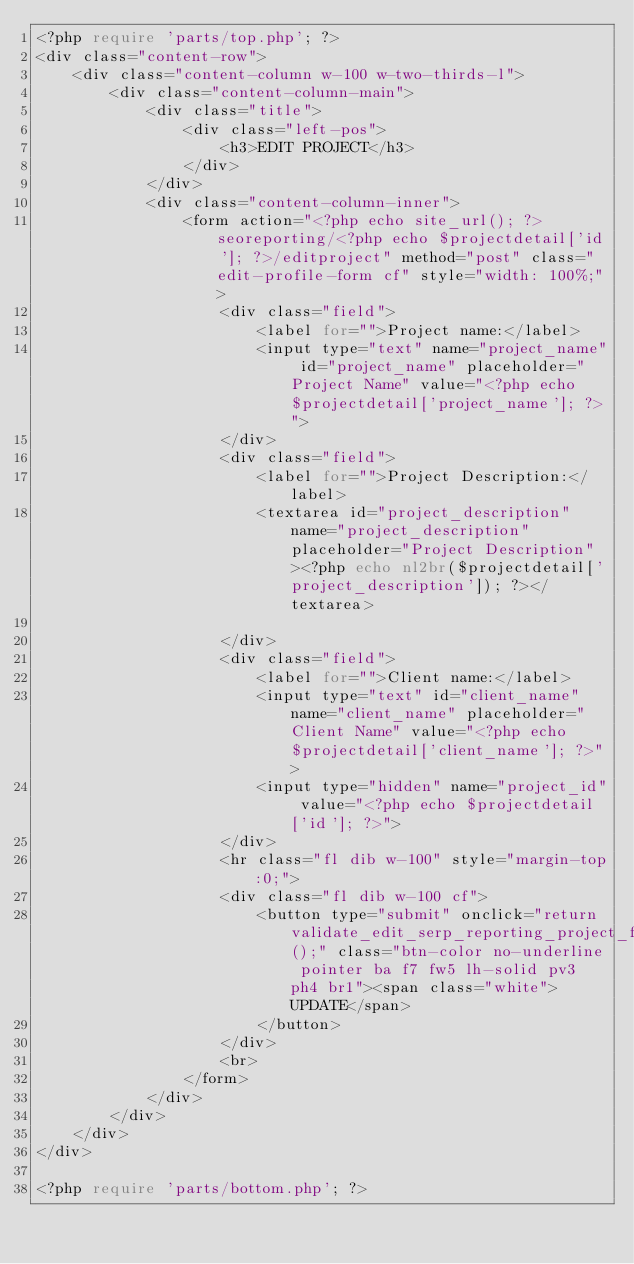Convert code to text. <code><loc_0><loc_0><loc_500><loc_500><_PHP_><?php require 'parts/top.php'; ?>
<div class="content-row">
    <div class="content-column w-100 w-two-thirds-l">
        <div class="content-column-main">
            <div class="title">
                <div class="left-pos">
                    <h3>EDIT PROJECT</h3>
                </div>
            </div>
            <div class="content-column-inner">
                <form action="<?php echo site_url(); ?>seoreporting/<?php echo $projectdetail['id']; ?>/editproject" method="post" class="edit-profile-form cf" style="width: 100%;">
                    <div class="field">
                        <label for="">Project name:</label>
                        <input type="text" name="project_name" id="project_name" placeholder="Project Name" value="<?php echo $projectdetail['project_name']; ?>">
                    </div>
                    <div class="field">
                        <label for="">Project Description:</label>
                        <textarea id="project_description" name="project_description" placeholder="Project Description"><?php echo nl2br($projectdetail['project_description']); ?></textarea>
                        
                    </div>
                    <div class="field">
                        <label for="">Client name:</label>
                        <input type="text" id="client_name" name="client_name" placeholder="Client Name" value="<?php echo $projectdetail['client_name']; ?>">
                        <input type="hidden" name="project_id" value="<?php echo $projectdetail['id']; ?>">
                    </div>
                    <hr class="fl dib w-100" style="margin-top:0;">
                    <div class="fl dib w-100 cf">
                        <button type="submit" onclick="return validate_edit_serp_reporting_project_form();" class="btn-color no-underline pointer ba f7 fw5 lh-solid pv3 ph4 br1"><span class="white">UPDATE</span>
                        </button>                       
                    </div>
                    <br>
                </form>
            </div>
        </div>
    </div>
</div>

<?php require 'parts/bottom.php'; ?>

</code> 